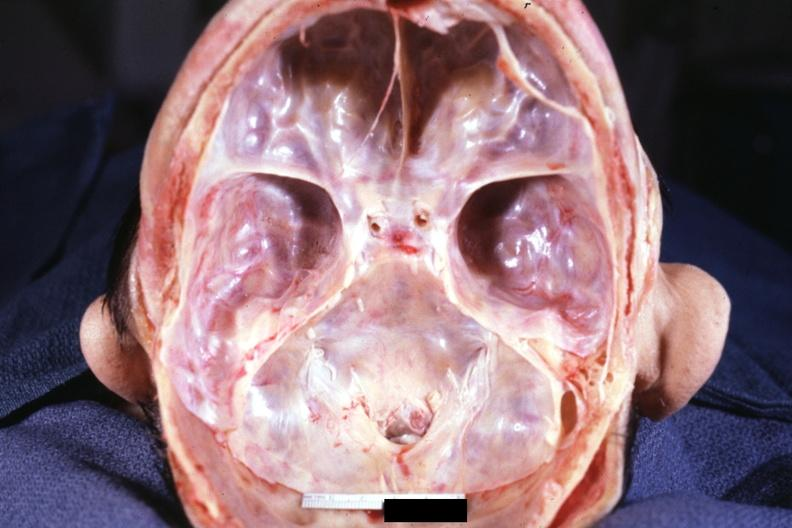why does this image show stenosis of foramen magnum?
Answer the question using a single word or phrase. Due to subluxation atlas vertebra case 31 